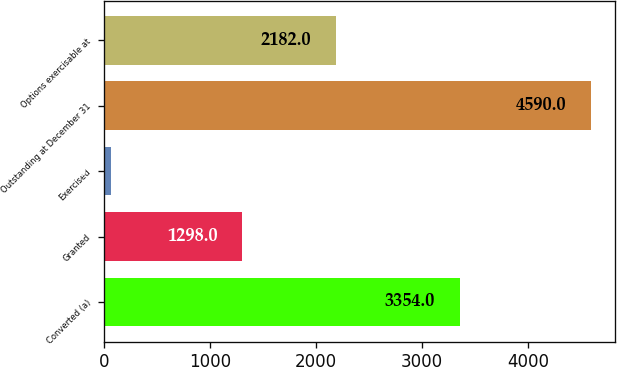Convert chart. <chart><loc_0><loc_0><loc_500><loc_500><bar_chart><fcel>Converted (a)<fcel>Granted<fcel>Exercised<fcel>Outstanding at December 31<fcel>Options exercisable at<nl><fcel>3354<fcel>1298<fcel>62<fcel>4590<fcel>2182<nl></chart> 